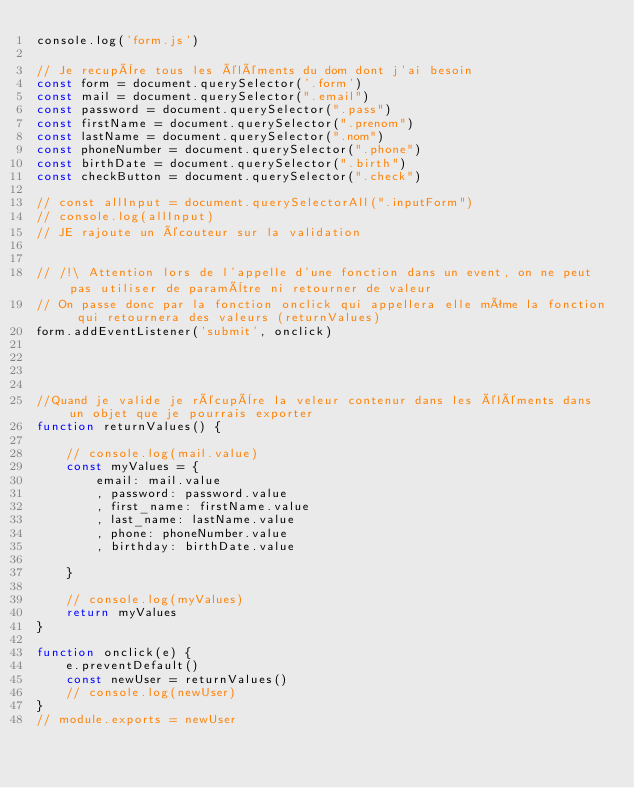<code> <loc_0><loc_0><loc_500><loc_500><_JavaScript_>console.log('form.js')

// Je recupère tous les éléments du dom dont j'ai besoin 
const form = document.querySelector('.form')
const mail = document.querySelector(".email")
const password = document.querySelector(".pass")
const firstName = document.querySelector(".prenom")
const lastName = document.querySelector(".nom")
const phoneNumber = document.querySelector(".phone")
const birthDate = document.querySelector(".birth")
const checkButton = document.querySelector(".check")

// const allInput = document.querySelectorAll(".inputForm")
// console.log(allInput)
// JE rajoute un écouteur sur la validation


// /!\ Attention lors de l'appelle d'une fonction dans un event, on ne peut pas utiliser de paramètre ni retourner de valeur 
// On passe donc par la fonction onclick qui appellera elle même la fonction qui retournera des valeurs (returnValues)
form.addEventListener('submit', onclick)




//Quand je valide je récupère la veleur contenur dans les éléments dans un objet que je pourrais exporter
function returnValues() {

    // console.log(mail.value)
    const myValues = {
        email: mail.value
        , password: password.value
        , first_name: firstName.value
        , last_name: lastName.value
        , phone: phoneNumber.value
        , birthday: birthDate.value

    }

    // console.log(myValues)
    return myValues
}

function onclick(e) {
    e.preventDefault()
    const newUser = returnValues()
    // console.log(newUser)
}
// module.exports = newUser</code> 